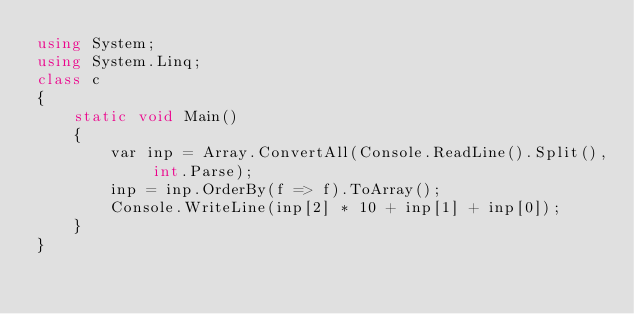Convert code to text. <code><loc_0><loc_0><loc_500><loc_500><_C#_>using System;
using System.Linq;
class c
{
    static void Main()
    {
        var inp = Array.ConvertAll(Console.ReadLine().Split(), int.Parse);
        inp = inp.OrderBy(f => f).ToArray();
        Console.WriteLine(inp[2] * 10 + inp[1] + inp[0]);
    }
}</code> 